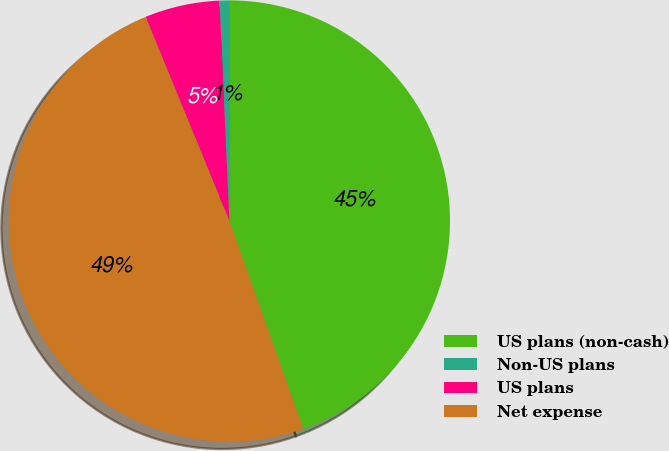Convert chart. <chart><loc_0><loc_0><loc_500><loc_500><pie_chart><fcel>US plans (non-cash)<fcel>Non-US plans<fcel>US plans<fcel>Net expense<nl><fcel>44.52%<fcel>0.76%<fcel>5.48%<fcel>49.24%<nl></chart> 